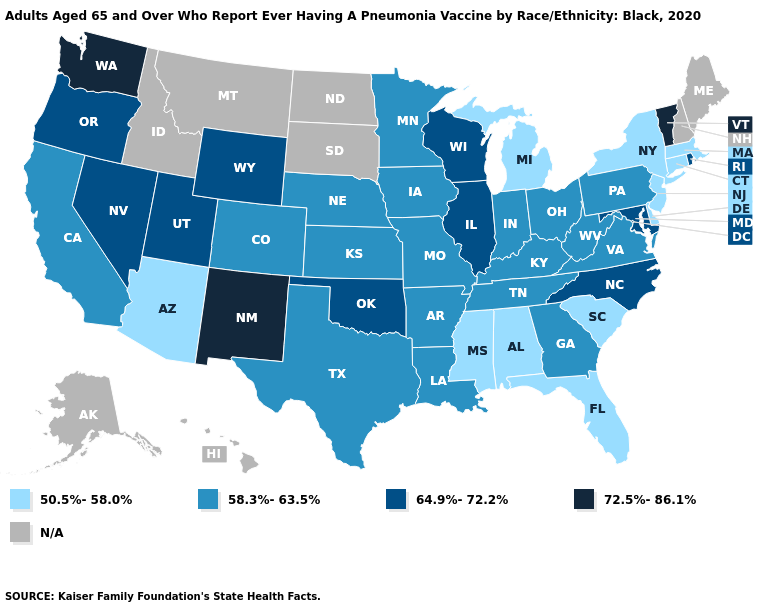Is the legend a continuous bar?
Quick response, please. No. Name the states that have a value in the range 58.3%-63.5%?
Be succinct. Arkansas, California, Colorado, Georgia, Indiana, Iowa, Kansas, Kentucky, Louisiana, Minnesota, Missouri, Nebraska, Ohio, Pennsylvania, Tennessee, Texas, Virginia, West Virginia. Name the states that have a value in the range 50.5%-58.0%?
Be succinct. Alabama, Arizona, Connecticut, Delaware, Florida, Massachusetts, Michigan, Mississippi, New Jersey, New York, South Carolina. What is the value of Virginia?
Give a very brief answer. 58.3%-63.5%. What is the lowest value in the West?
Short answer required. 50.5%-58.0%. Which states hav the highest value in the MidWest?
Be succinct. Illinois, Wisconsin. What is the value of Hawaii?
Write a very short answer. N/A. Does the first symbol in the legend represent the smallest category?
Concise answer only. Yes. What is the lowest value in the West?
Concise answer only. 50.5%-58.0%. Is the legend a continuous bar?
Quick response, please. No. What is the highest value in the South ?
Answer briefly. 64.9%-72.2%. What is the lowest value in the USA?
Short answer required. 50.5%-58.0%. Name the states that have a value in the range 72.5%-86.1%?
Short answer required. New Mexico, Vermont, Washington. Does New Jersey have the highest value in the USA?
Keep it brief. No. 